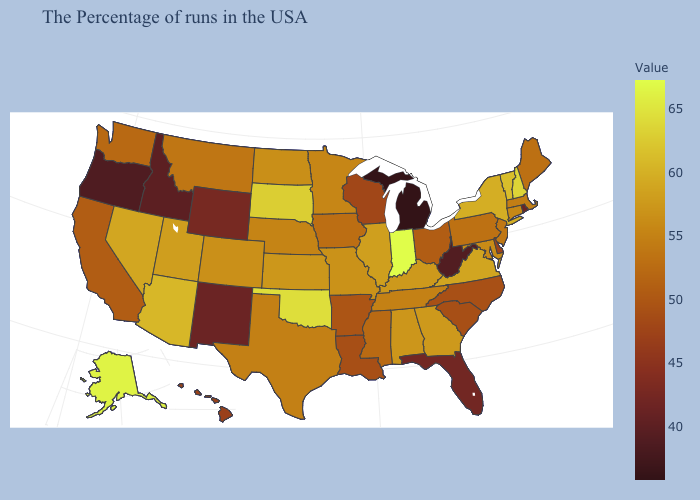Is the legend a continuous bar?
Give a very brief answer. Yes. Which states hav the highest value in the South?
Short answer required. Oklahoma. Which states have the lowest value in the USA?
Answer briefly. Michigan. Does the map have missing data?
Answer briefly. No. Does Massachusetts have a higher value than Louisiana?
Quick response, please. Yes. Is the legend a continuous bar?
Give a very brief answer. Yes. 